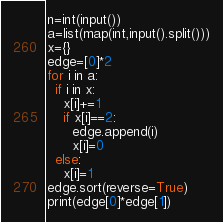Convert code to text. <code><loc_0><loc_0><loc_500><loc_500><_Python_>n=int(input())
a=list(map(int,input().split()))
x={}
edge=[0]*2
for i in a:
  if i in x:
    x[i]+=1
    if x[i]==2:
      edge.append(i)
      x[i]=0
  else:
    x[i]=1
edge.sort(reverse=True)
print(edge[0]*edge[1])</code> 